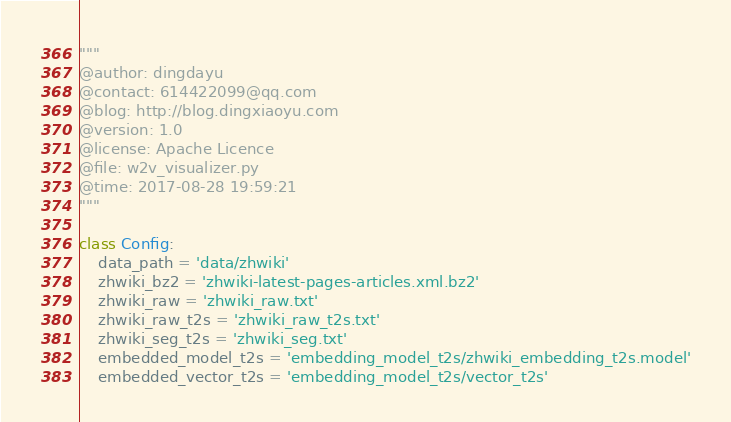<code> <loc_0><loc_0><loc_500><loc_500><_Python_>
"""
@author: dingdayu
@contact: 614422099@qq.com
@blog: http://blog.dingxiaoyu.com
@version: 1.0
@license: Apache Licence
@file: w2v_visualizer.py
@time: 2017-08-28 19:59:21
"""

class Config:
    data_path = 'data/zhwiki'
    zhwiki_bz2 = 'zhwiki-latest-pages-articles.xml.bz2'
    zhwiki_raw = 'zhwiki_raw.txt'
    zhwiki_raw_t2s = 'zhwiki_raw_t2s.txt'
    zhwiki_seg_t2s = 'zhwiki_seg.txt'
    embedded_model_t2s = 'embedding_model_t2s/zhwiki_embedding_t2s.model'
    embedded_vector_t2s = 'embedding_model_t2s/vector_t2s'
</code> 